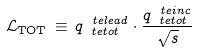<formula> <loc_0><loc_0><loc_500><loc_500>\mathcal { L } _ { \text {TOT} } \, \equiv \, q ^ { \ t e { l e a d } } _ { \ t e { t o t } } \cdot \frac { q ^ { \ t e { i n c } } _ { \ t e { t o t } } } { \sqrt { s } }</formula> 